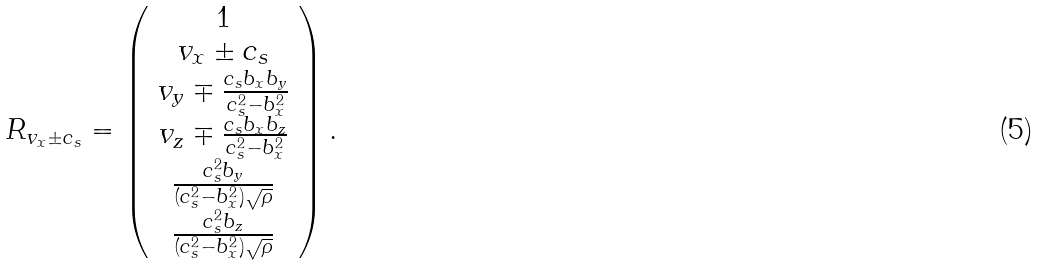Convert formula to latex. <formula><loc_0><loc_0><loc_500><loc_500>R _ { v _ { x } \pm c _ { s } } = \left ( \begin{array} { c } 1 \\ v _ { x } \pm c _ { s } \\ v _ { y } \mp \frac { c _ { s } b _ { x } b _ { y } } { c _ { s } ^ { 2 } - b _ { x } ^ { 2 } } \\ v _ { z } \mp \frac { c _ { s } b _ { x } b _ { z } } { c _ { s } ^ { 2 } - b _ { x } ^ { 2 } } \\ \frac { c _ { s } ^ { 2 } b _ { y } } { ( c _ { s } ^ { 2 } - b _ { x } ^ { 2 } ) \sqrt { \rho } } \\ \frac { c _ { s } ^ { 2 } b _ { z } } { ( c _ { s } ^ { 2 } - b _ { x } ^ { 2 } ) \sqrt { \rho } } \end{array} \right ) .</formula> 